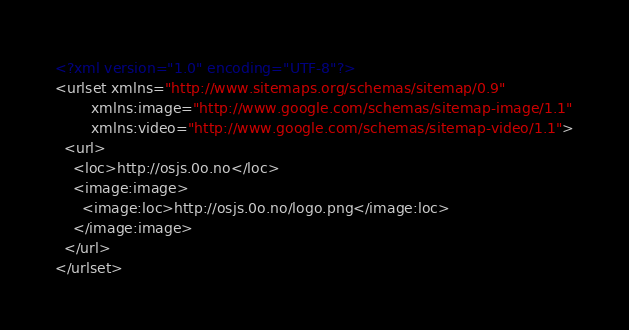<code> <loc_0><loc_0><loc_500><loc_500><_XML_><?xml version="1.0" encoding="UTF-8"?>
<urlset xmlns="http://www.sitemaps.org/schemas/sitemap/0.9"
        xmlns:image="http://www.google.com/schemas/sitemap-image/1.1"
        xmlns:video="http://www.google.com/schemas/sitemap-video/1.1">
  <url>
    <loc>http://osjs.0o.no</loc>
    <image:image>
      <image:loc>http://osjs.0o.no/logo.png</image:loc>
    </image:image>
  </url>
</urlset>
</code> 